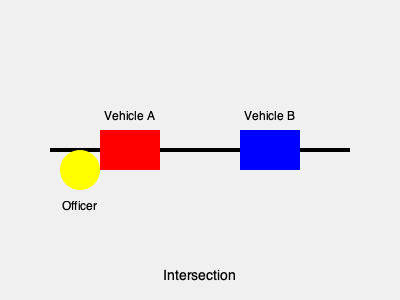In the diagram, Vehicle A (red) and Vehicle B (blue) are involved in a collision at an intersection. As the responding officer (yellow), what is the primary action you should take to ensure proper traffic law enforcement procedures are followed? 1. Assess the scene: The officer must first ensure the safety of all parties involved and secure the area to prevent further accidents.

2. Check for injuries: Immediately check if anyone requires medical attention and call for emergency services if needed.

3. Gather information: Collect driver's licenses, vehicle registrations, and insurance information from both drivers.

4. Interview witnesses: Speak with any bystanders who may have witnessed the collision to gather additional perspectives.

5. Document the scene: Take photographs of the vehicles' positions, damage, and any relevant road signs or signals.

6. Measure and diagram: Create a detailed sketch of the accident scene, including vehicle positions and road conditions.

7. Determine violations: Based on the evidence and interviews, assess if any traffic laws were violated by either driver.

8. Issue citations: If applicable, issue appropriate citations for any traffic law violations.

9. Complete accident report: Fill out a comprehensive accident report detailing all gathered information and observations.

10. Clear the scene: Once all necessary information is collected, ensure the vehicles are moved to restore normal traffic flow.

The primary action that encompasses all these steps and ensures proper traffic law enforcement procedures are followed is to conduct a thorough investigation of the accident scene.
Answer: Conduct a thorough investigation 